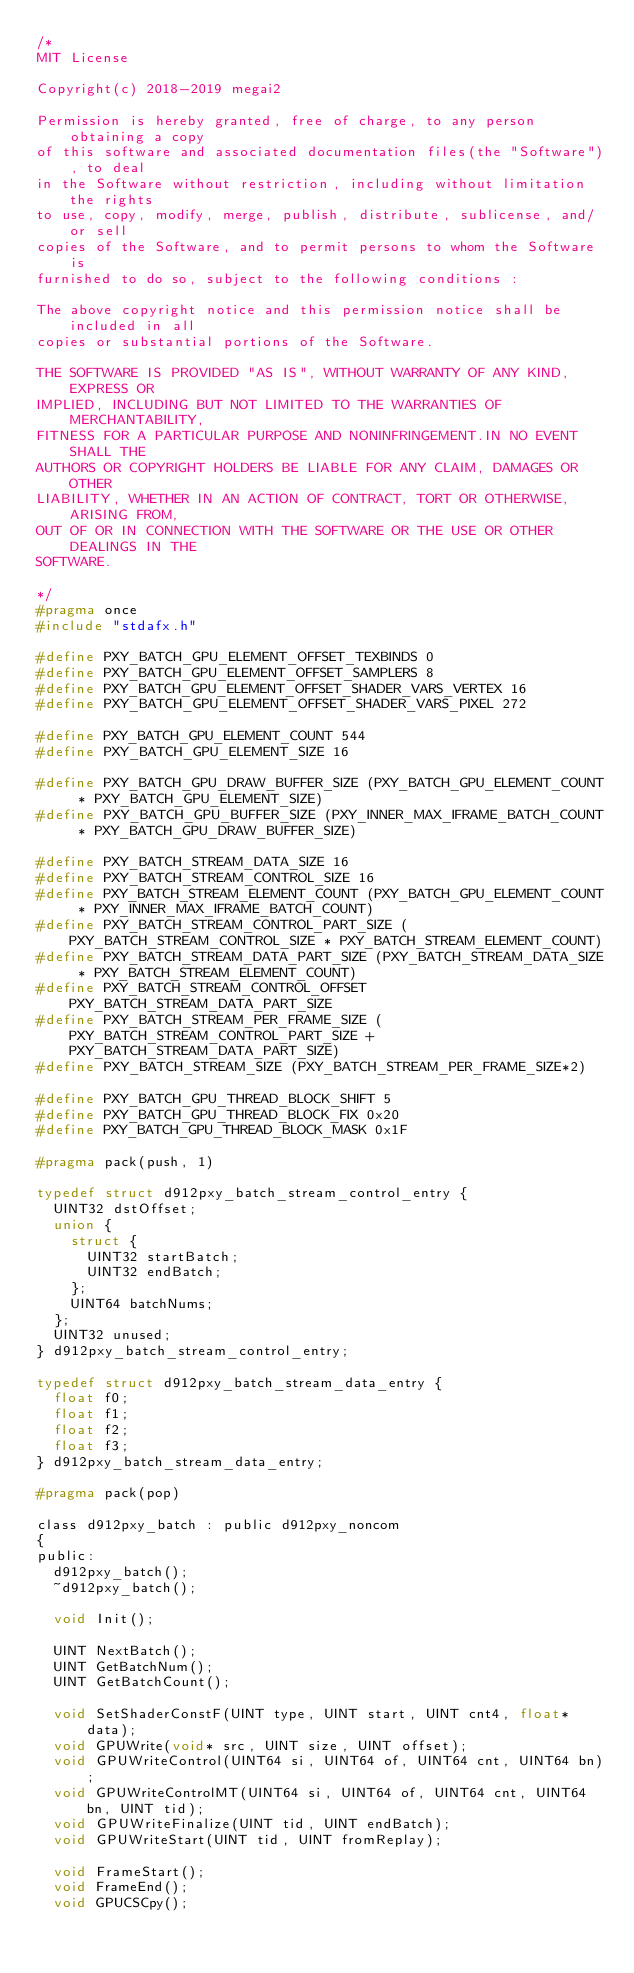Convert code to text. <code><loc_0><loc_0><loc_500><loc_500><_C_>/*
MIT License

Copyright(c) 2018-2019 megai2

Permission is hereby granted, free of charge, to any person obtaining a copy
of this software and associated documentation files(the "Software"), to deal
in the Software without restriction, including without limitation the rights
to use, copy, modify, merge, publish, distribute, sublicense, and/or sell
copies of the Software, and to permit persons to whom the Software is
furnished to do so, subject to the following conditions :

The above copyright notice and this permission notice shall be included in all
copies or substantial portions of the Software.

THE SOFTWARE IS PROVIDED "AS IS", WITHOUT WARRANTY OF ANY KIND, EXPRESS OR
IMPLIED, INCLUDING BUT NOT LIMITED TO THE WARRANTIES OF MERCHANTABILITY,
FITNESS FOR A PARTICULAR PURPOSE AND NONINFRINGEMENT.IN NO EVENT SHALL THE
AUTHORS OR COPYRIGHT HOLDERS BE LIABLE FOR ANY CLAIM, DAMAGES OR OTHER
LIABILITY, WHETHER IN AN ACTION OF CONTRACT, TORT OR OTHERWISE, ARISING FROM,
OUT OF OR IN CONNECTION WITH THE SOFTWARE OR THE USE OR OTHER DEALINGS IN THE
SOFTWARE.

*/
#pragma once
#include "stdafx.h"

#define PXY_BATCH_GPU_ELEMENT_OFFSET_TEXBINDS 0
#define PXY_BATCH_GPU_ELEMENT_OFFSET_SAMPLERS 8
#define PXY_BATCH_GPU_ELEMENT_OFFSET_SHADER_VARS_VERTEX 16
#define PXY_BATCH_GPU_ELEMENT_OFFSET_SHADER_VARS_PIXEL 272

#define PXY_BATCH_GPU_ELEMENT_COUNT 544
#define PXY_BATCH_GPU_ELEMENT_SIZE 16

#define PXY_BATCH_GPU_DRAW_BUFFER_SIZE (PXY_BATCH_GPU_ELEMENT_COUNT * PXY_BATCH_GPU_ELEMENT_SIZE)
#define PXY_BATCH_GPU_BUFFER_SIZE (PXY_INNER_MAX_IFRAME_BATCH_COUNT * PXY_BATCH_GPU_DRAW_BUFFER_SIZE)

#define PXY_BATCH_STREAM_DATA_SIZE 16
#define PXY_BATCH_STREAM_CONTROL_SIZE 16
#define PXY_BATCH_STREAM_ELEMENT_COUNT (PXY_BATCH_GPU_ELEMENT_COUNT * PXY_INNER_MAX_IFRAME_BATCH_COUNT)
#define PXY_BATCH_STREAM_CONTROL_PART_SIZE (PXY_BATCH_STREAM_CONTROL_SIZE * PXY_BATCH_STREAM_ELEMENT_COUNT)
#define PXY_BATCH_STREAM_DATA_PART_SIZE (PXY_BATCH_STREAM_DATA_SIZE * PXY_BATCH_STREAM_ELEMENT_COUNT)
#define PXY_BATCH_STREAM_CONTROL_OFFSET PXY_BATCH_STREAM_DATA_PART_SIZE
#define PXY_BATCH_STREAM_PER_FRAME_SIZE (PXY_BATCH_STREAM_CONTROL_PART_SIZE + PXY_BATCH_STREAM_DATA_PART_SIZE)
#define PXY_BATCH_STREAM_SIZE (PXY_BATCH_STREAM_PER_FRAME_SIZE*2)

#define PXY_BATCH_GPU_THREAD_BLOCK_SHIFT 5
#define PXY_BATCH_GPU_THREAD_BLOCK_FIX 0x20
#define PXY_BATCH_GPU_THREAD_BLOCK_MASK 0x1F

#pragma pack(push, 1)

typedef struct d912pxy_batch_stream_control_entry {
	UINT32 dstOffset;
	union {
		struct {
			UINT32 startBatch;
			UINT32 endBatch;
		};
		UINT64 batchNums;
	};
	UINT32 unused;
} d912pxy_batch_stream_control_entry;

typedef struct d912pxy_batch_stream_data_entry {
	float f0;
	float f1;
	float f2;
	float f3;
} d912pxy_batch_stream_data_entry;

#pragma pack(pop)

class d912pxy_batch : public d912pxy_noncom
{
public:
	d912pxy_batch();
	~d912pxy_batch();

	void Init();

	UINT NextBatch();
	UINT GetBatchNum();
	UINT GetBatchCount();

	void SetShaderConstF(UINT type, UINT start, UINT cnt4, float* data);
	void GPUWrite(void* src, UINT size, UINT offset);
	void GPUWriteControl(UINT64 si, UINT64 of, UINT64 cnt, UINT64 bn);	
	void GPUWriteControlMT(UINT64 si, UINT64 of, UINT64 cnt, UINT64 bn, UINT tid);
	void GPUWriteFinalize(UINT tid, UINT endBatch);	
	void GPUWriteStart(UINT tid, UINT fromReplay);

	void FrameStart();
	void FrameEnd();
	void GPUCSCpy();
	</code> 